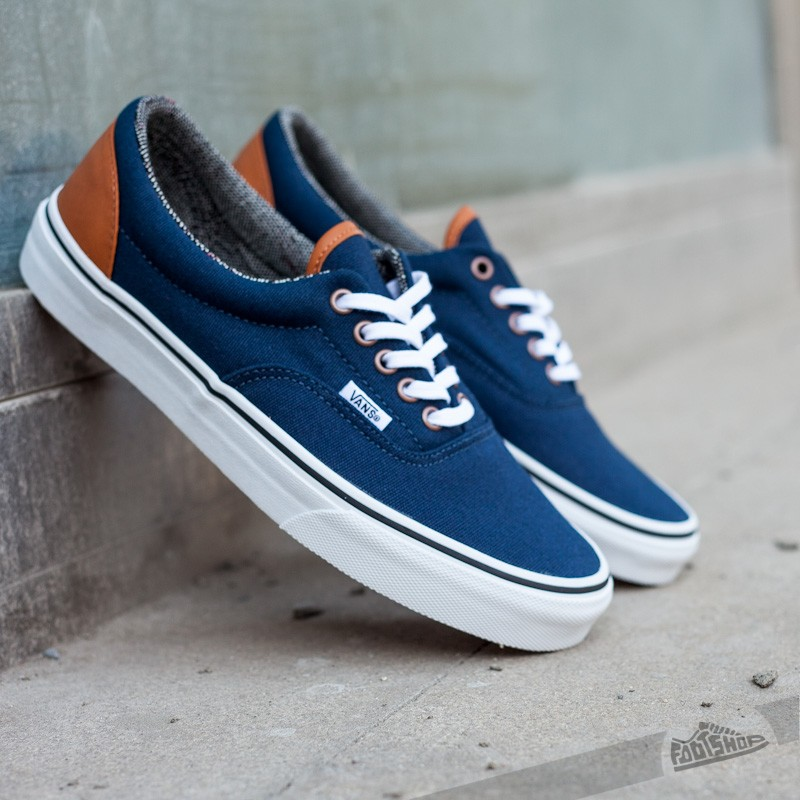How many eyelets are there on one sneaker, and what might this indicate about the lacing options and fit adjustment capabilities? There are five eyelets visible on one sneaker. This design choice is likely aimed at ensuring a secure and comfortable fit, suitable for casual wear. With five eyelets, wearers have a moderate range of lacing options that enable fine-tuning of fit around the instep and across the width of the foot. This can accommodate various foot shapes and sizes, providing both comfort and stability. Additionally, fewer eyelets can simplify the lacing process and expedite putting on and taking off the sneakers. 